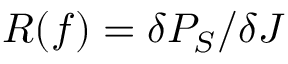<formula> <loc_0><loc_0><loc_500><loc_500>R ( f ) = \delta P _ { S } / \delta J</formula> 